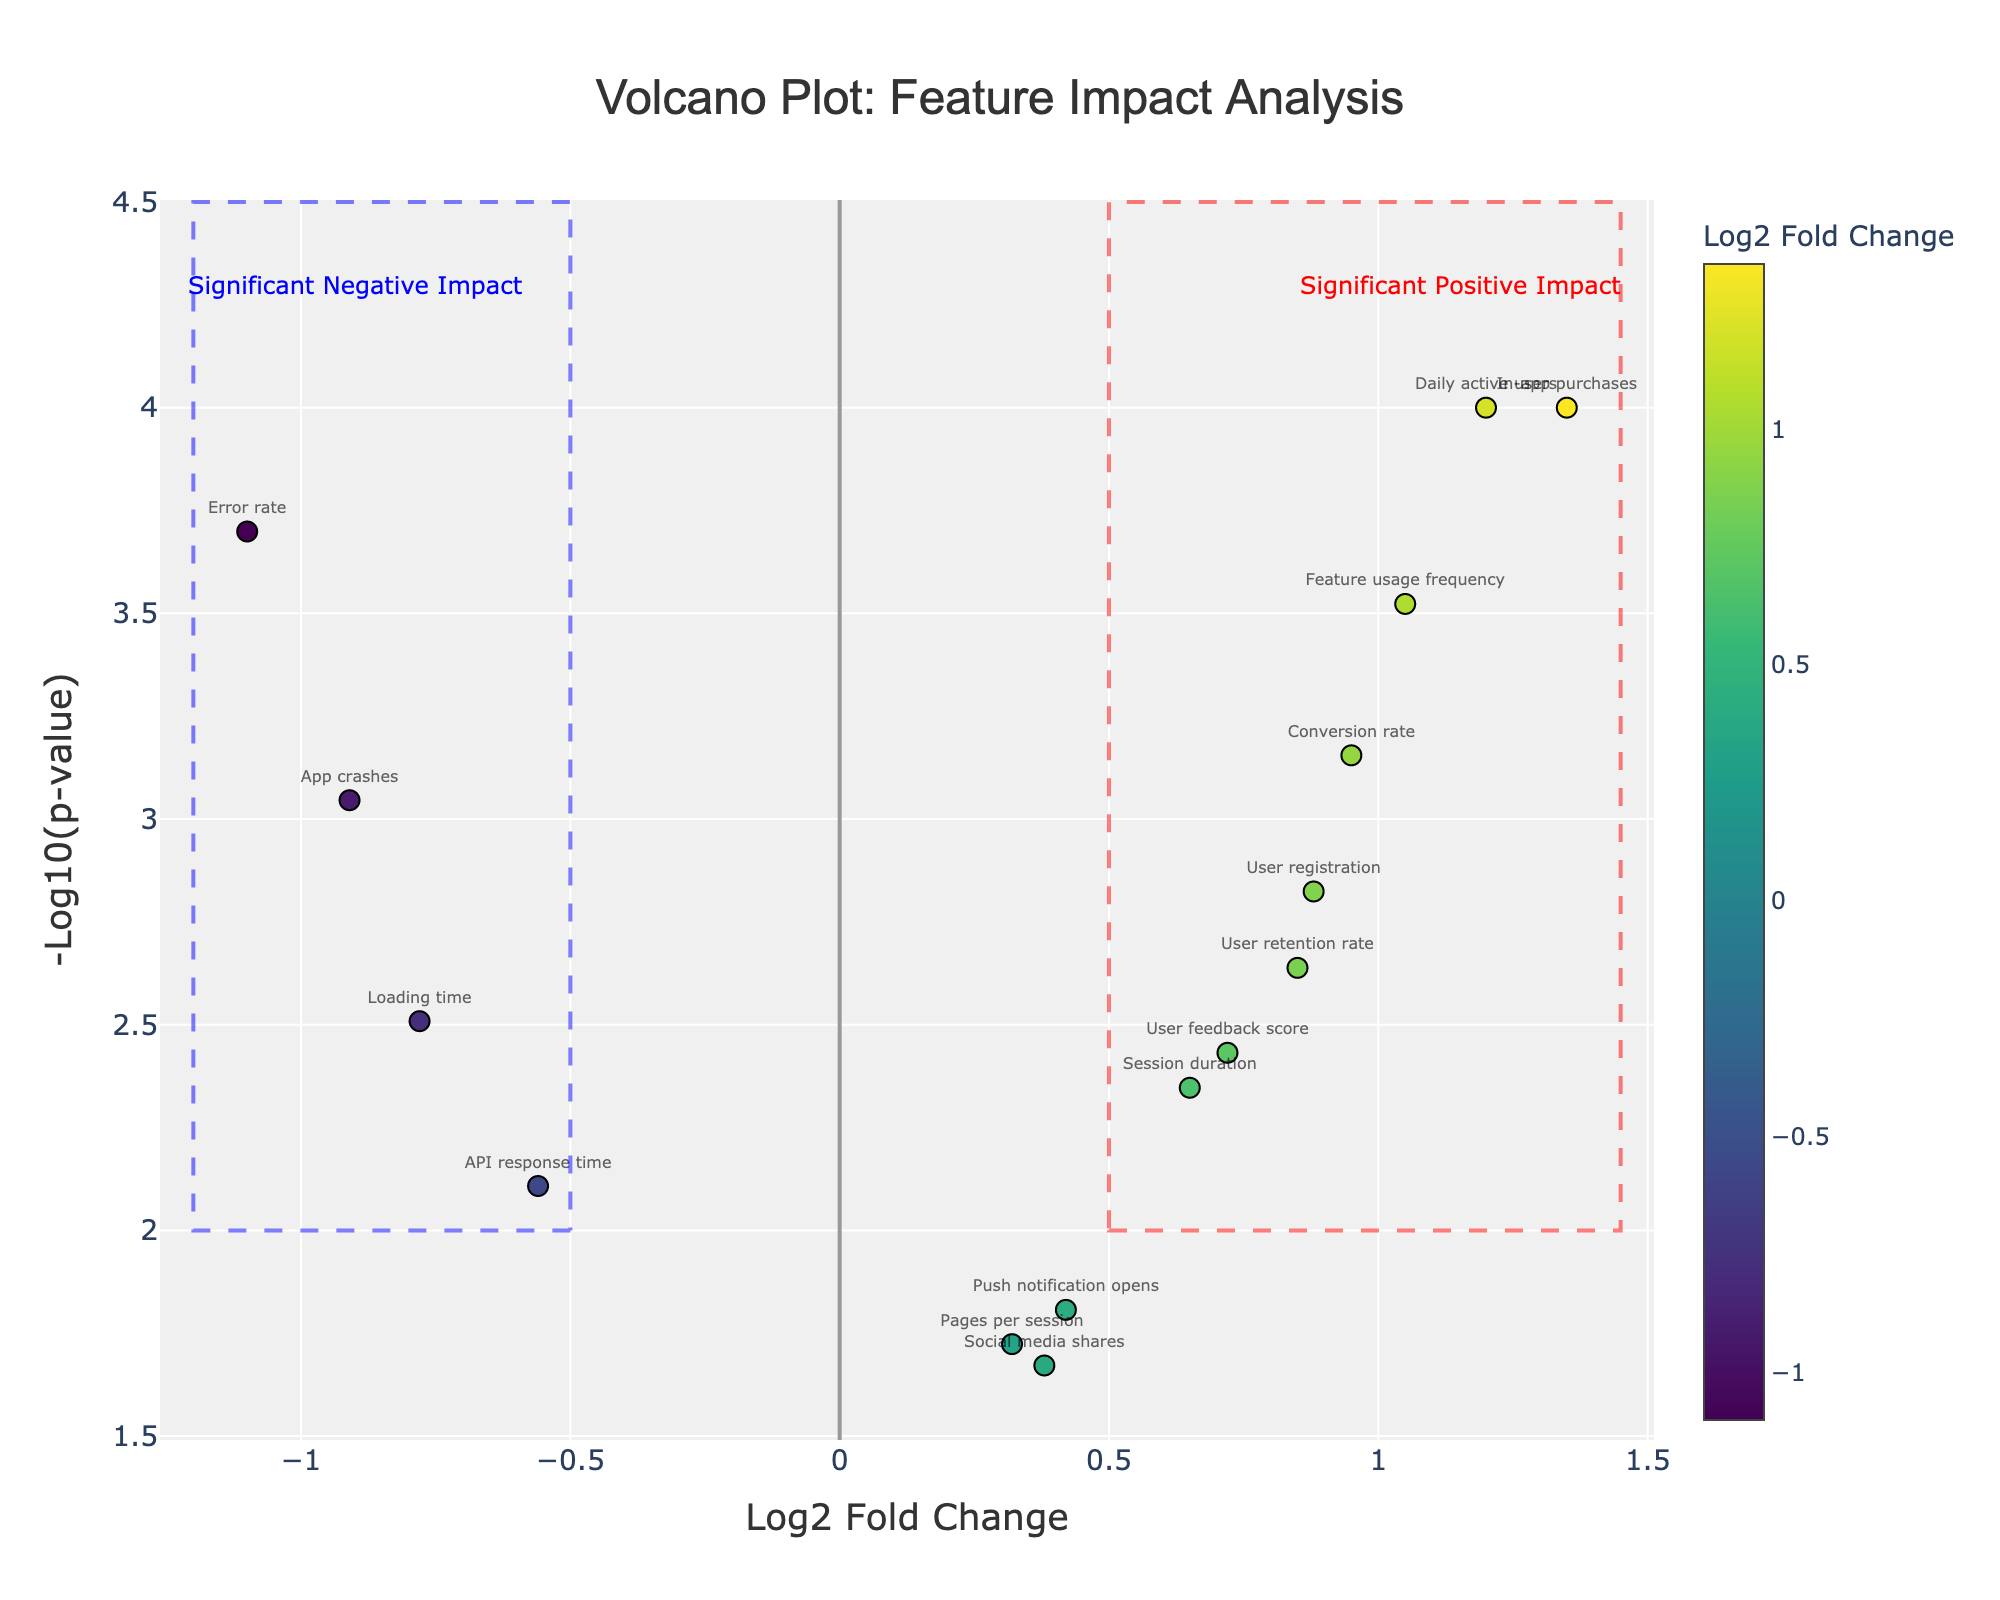What is the title of the figure? The title is located at the top of the figure and typically describes the main topic. In this case, it states: "Volcano Plot: Feature Impact Analysis".
Answer: Volcano Plot: Feature Impact Analysis How many features have a positive log2 fold change? To determine the features with positive log2 fold changes, look at the points positioned to the right of the vertical line at x=0. Count these points.
Answer: 10 Which feature has the highest -log10(p-value)? Identify the point with the highest y-value. The hover text or the annotations near the top can help in identifying this feature.
Answer: In-app purchases What does the color of the points represent? The color scale bar on the side of the figure indicates what the colors represent. It shows different shades corresponding to the Log2 Fold Change values.
Answer: Log2 Fold Change Which feature has the most significant negative impact and what is its log2 fold change value? Significant negative impact features are on the left side. Among them, the farthest left point is "Error rate". The log2 fold change value is visible in the hover text.
Answer: Error rate, -1.1 How many features have a p-value less than 0.01? Look at the y-axis where -log10(0.01) equals 2. Count the points above y=2 to find the number of features meeting this criterion.
Answer: 9 Which feature shows an improved user engagement after implementing new features as indicated by a high log2 fold change and low p-value? Positive log2 fold change indicates improvement, and low p-value adds significance. The point farthest to the top-right, reading the hover text, indicates "Daily active users".
Answer: Daily active users Compare the impact of ‘User retention rate’ and ‘Loading time’: which has a greater magnitude of log2 fold change? Looking at their positions on the x-axis, compare their distances from the center. One is 0.85 and the other is -0.78.
Answer: User retention rate Which feature is positioned near the center of the plot and what does it imply about the feature's change? Features near the vertical x=0 line have little to no change. For example, "Pages per session".
Answer: Pages per session, minimal change What is the maximum value of -log10(p-value) depicted in the plot? Check the highest point on the y-axis and the corresponding annotation or hover text. This value indicates the smallest p-value.
Answer: 4 